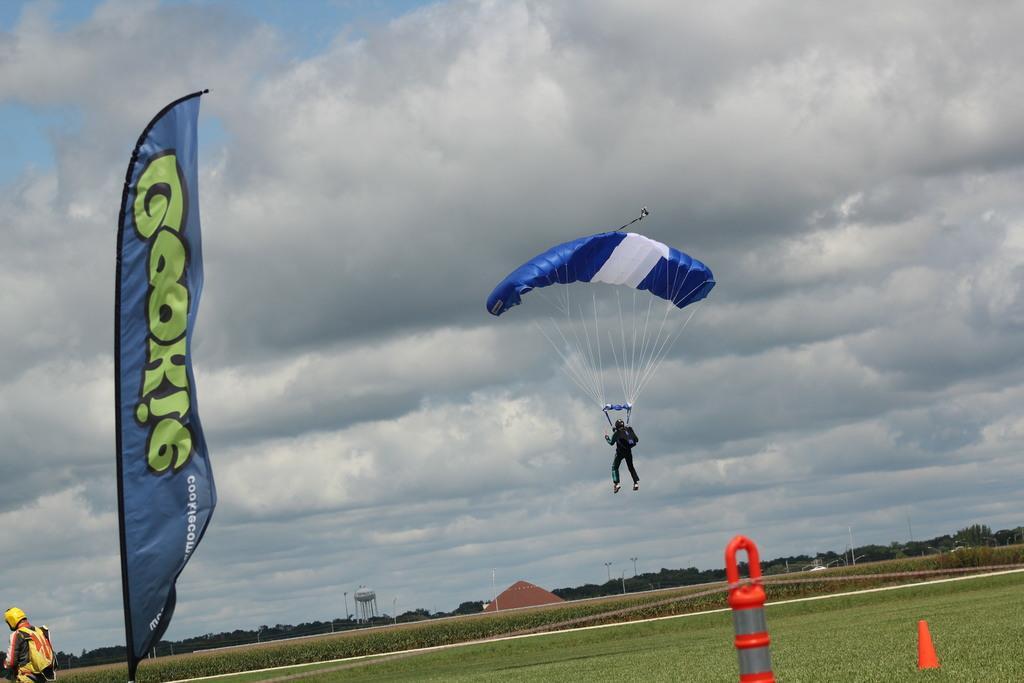Describe this image in one or two sentences. As we can see in the image there is a banner, two people, parachute, water pipe and grass. In the background there are trees. On the top there is sky and clouds. 